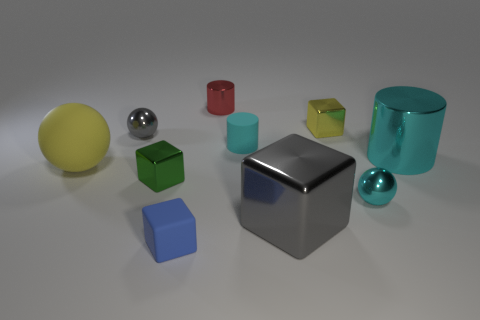Do the red object and the gray cube have the same size?
Make the answer very short. No. There is a yellow thing to the right of the blue matte block; is it the same size as the red metal cylinder?
Offer a very short reply. Yes. There is a rubber thing on the right side of the small red object; what is its color?
Ensure brevity in your answer.  Cyan. What number of yellow objects are there?
Provide a succinct answer. 2. There is a cyan object that is the same material as the large cylinder; what shape is it?
Give a very brief answer. Sphere. Is the color of the object that is on the right side of the tiny cyan metal thing the same as the tiny metallic ball right of the tiny red metal thing?
Provide a succinct answer. Yes. Are there the same number of matte spheres in front of the tiny yellow metal object and big blocks?
Provide a succinct answer. Yes. There is a yellow rubber sphere; how many yellow rubber spheres are to the left of it?
Make the answer very short. 0. The green metal block has what size?
Your answer should be very brief. Small. The ball that is the same material as the blue object is what color?
Give a very brief answer. Yellow. 